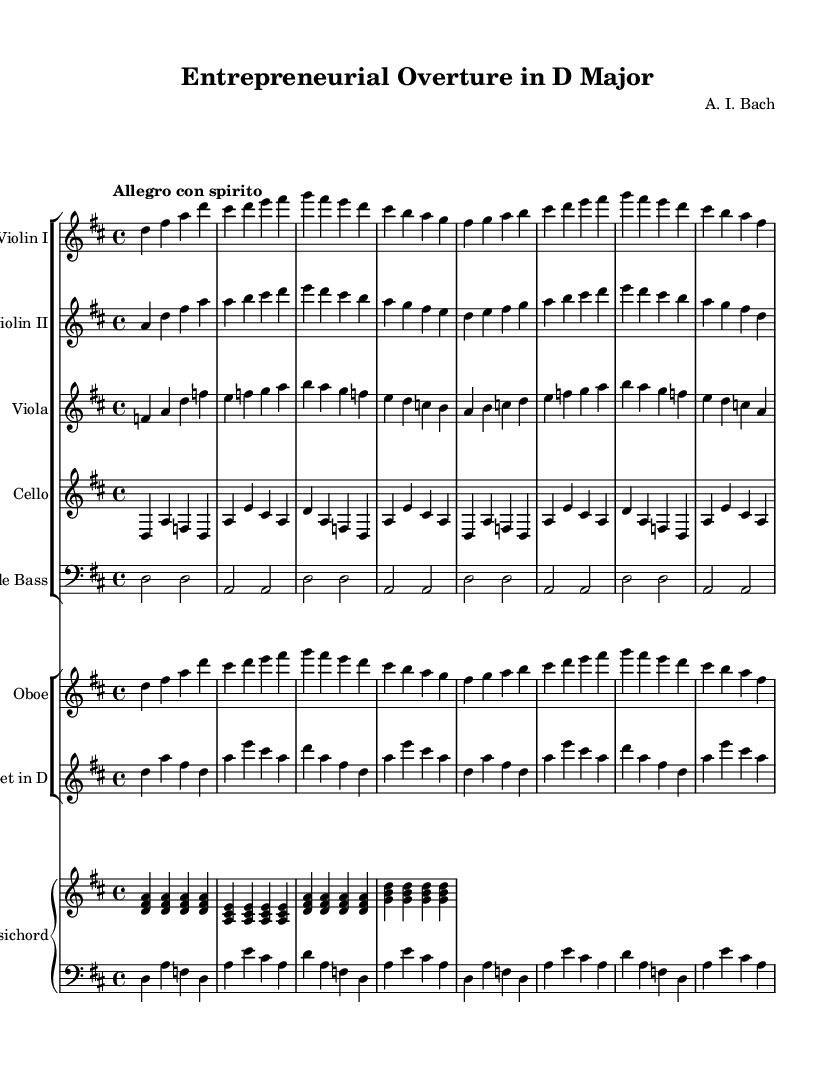What is the key signature of this music? The key signature is indicated by the sharps or flats at the beginning of the staff. In this case, there are two sharps (F# and C#), which identify the key as D major.
Answer: D major What is the time signature of this piece? The time signature is shown at the beginning of the sheet music and indicates how many beats are in each measure. Here, the time signature is 4/4, which means there are four beats per measure.
Answer: 4/4 What is the tempo marking of this composition? The tempo marking is specified at the beginning of the piece, indicating the speed of the music. The notation "Allegro con spirito" suggests a fast tempo with lively spirit.
Answer: Allegro con spirito How many instruments are featured in this piece? The score layout shows different staves for different instruments. Counting the staved sections reveals eight instruments: Violin I, Violin II, Viola, Cello, Double Bass, Oboe, Trumpet, and Harpsichord.
Answer: Eight Which section of the orchestra plays the melody primarily? The melody primarily appears in the first violins, which often carry the main theme in orchestral piece settings. The Violin I part is distinctively higher and plays more melodic lines than other sections.
Answer: Violin I What title is given to this orchestral piece? The title is typically at the top of the sheet music, indicating the name of the piece. Here, the title "Entrepreneurial Overture in D Major" reflects the celebratory theme of entrepreneurship.
Answer: Entrepreneurial Overture in D Major What instrument provides harmonic support in this composition? The harpsichord, indicated in the score, serves as the primary instrument for harmonic support, providing chords and rhythmic accompaniment typical of Baroque orchestration.
Answer: Harpsichord 